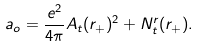Convert formula to latex. <formula><loc_0><loc_0><loc_500><loc_500>a _ { o } = \frac { e ^ { 2 } } { 4 \pi } A _ { t } ( r _ { + } ) ^ { 2 } + N _ { t } ^ { r } ( r _ { + } ) . \label a { a o d e c i d e d }</formula> 